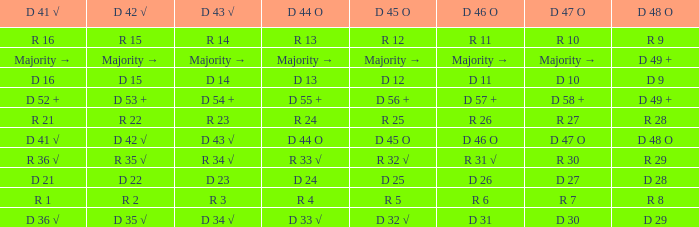Name the D 45 O with D 46 O of r 31 √ R 32 √. 